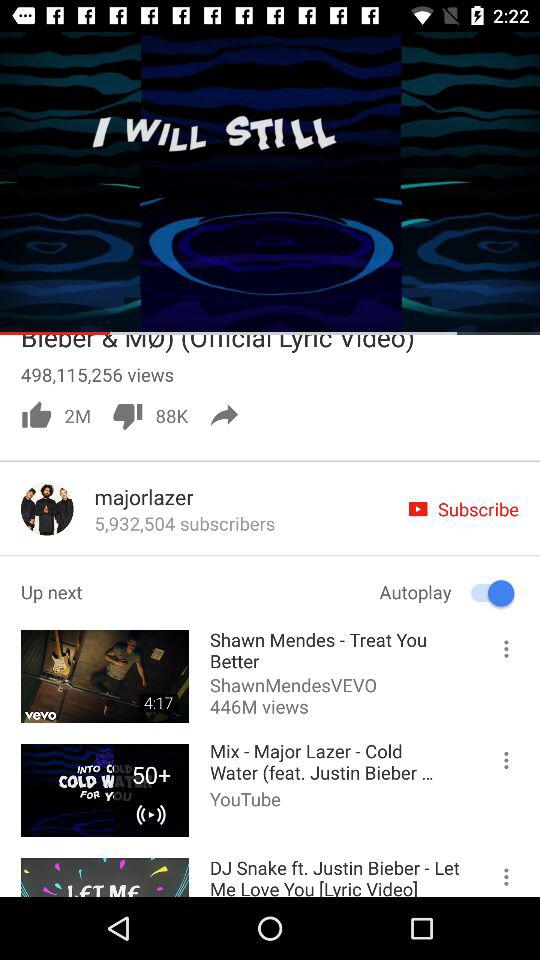What is the status of "Autoplay"? The status of "Autoplay" is "on". 